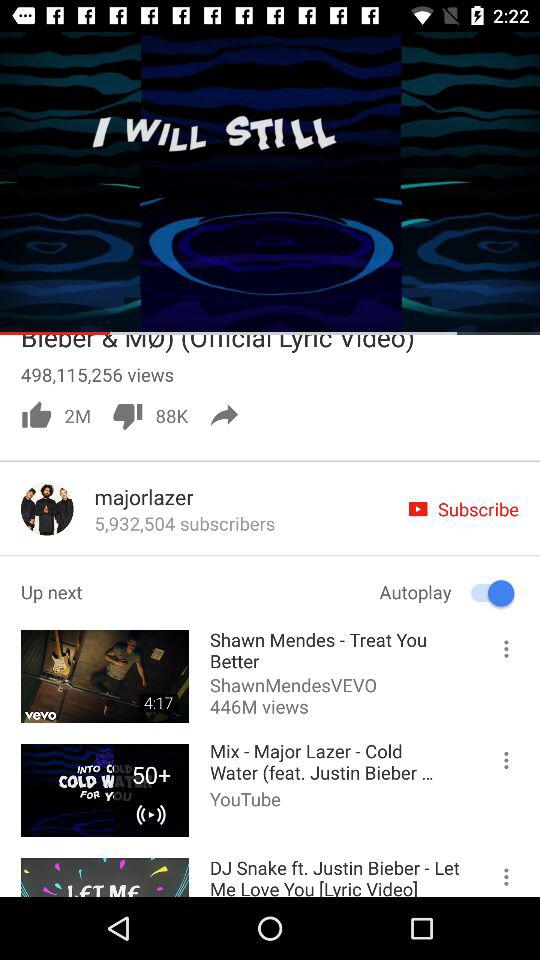What is the status of "Autoplay"? The status of "Autoplay" is "on". 